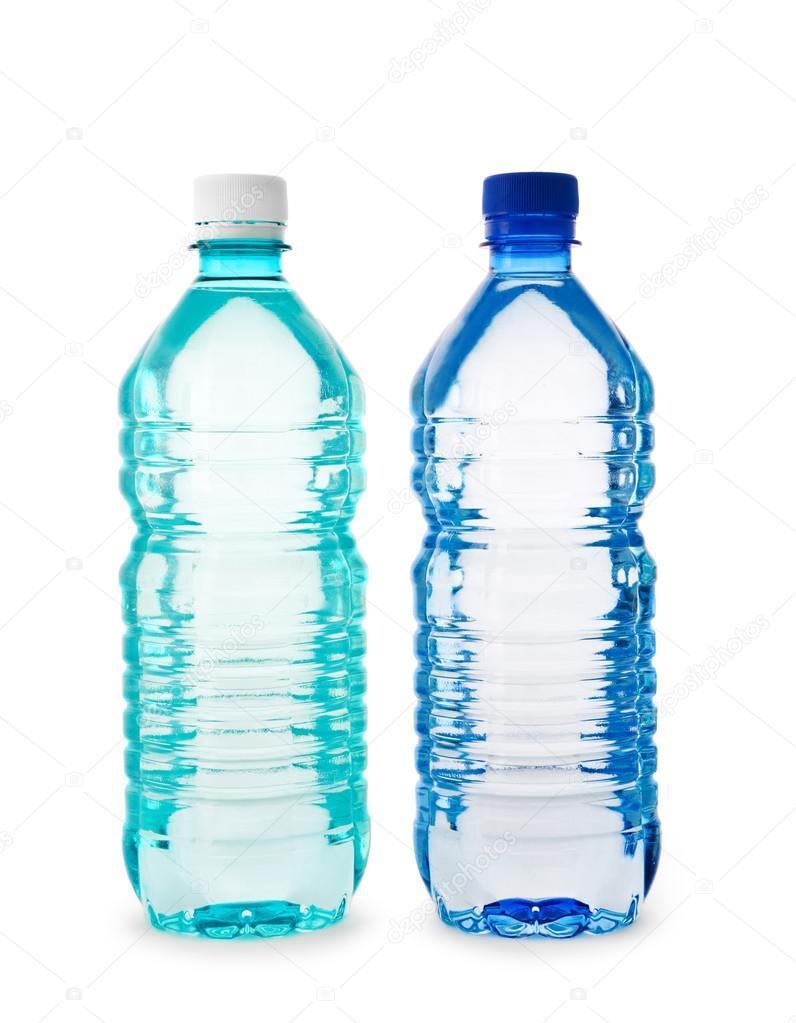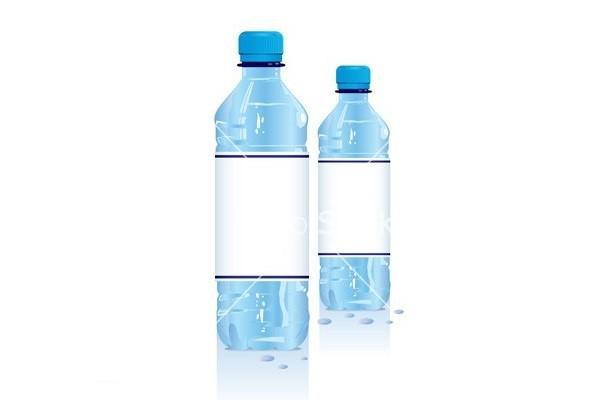The first image is the image on the left, the second image is the image on the right. Analyze the images presented: Is the assertion "An image shows exactly two lidded, unlabeled water bottles of the same size and shape, displayed level and side-by-side." valid? Answer yes or no. Yes. The first image is the image on the left, the second image is the image on the right. Given the left and right images, does the statement "There are five bottles in total." hold true? Answer yes or no. No. 